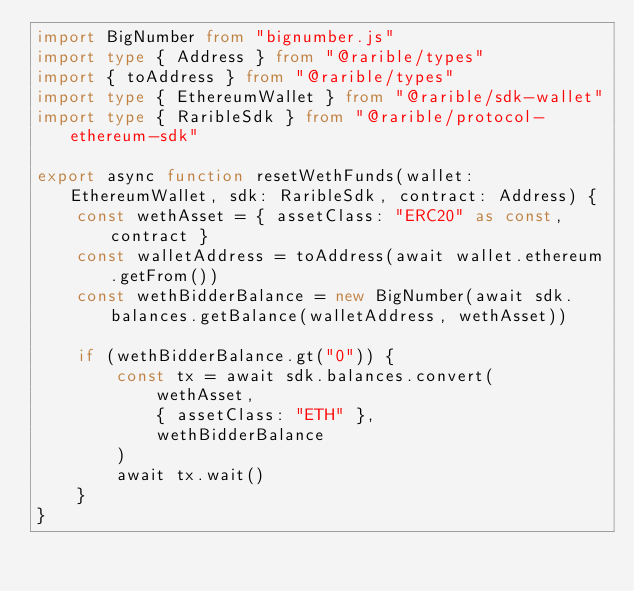<code> <loc_0><loc_0><loc_500><loc_500><_TypeScript_>import BigNumber from "bignumber.js"
import type { Address } from "@rarible/types"
import { toAddress } from "@rarible/types"
import type { EthereumWallet } from "@rarible/sdk-wallet"
import type { RaribleSdk } from "@rarible/protocol-ethereum-sdk"

export async function resetWethFunds(wallet: EthereumWallet, sdk: RaribleSdk, contract: Address) {
	const wethAsset = { assetClass: "ERC20" as const, contract }
	const walletAddress = toAddress(await wallet.ethereum.getFrom())
	const wethBidderBalance = new BigNumber(await sdk.balances.getBalance(walletAddress, wethAsset))

	if (wethBidderBalance.gt("0")) {
		const tx = await sdk.balances.convert(
			wethAsset,
			{ assetClass: "ETH" },
			wethBidderBalance
		)
		await tx.wait()
	}
}
</code> 